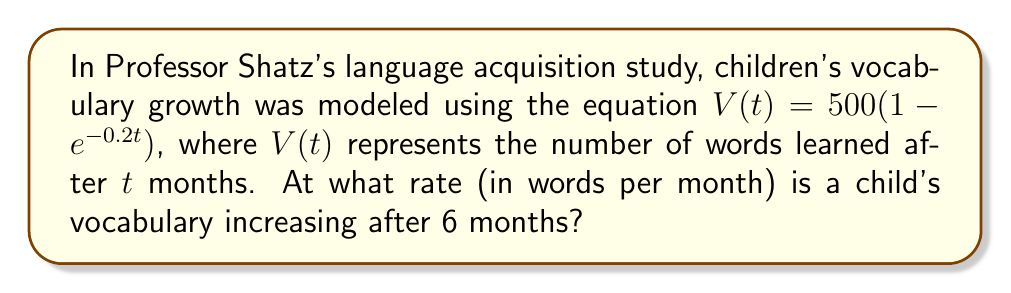Provide a solution to this math problem. To find the rate of vocabulary increase at 6 months, we need to find the derivative of the given function and evaluate it at $t = 6$.

1. The given function is $V(t) = 500(1 - e^{-0.2t})$

2. To find the derivative, we use the chain rule:
   $$\frac{dV}{dt} = 500 \cdot \frac{d}{dt}(1 - e^{-0.2t})$$
   $$\frac{dV}{dt} = 500 \cdot (0 - (-0.2)e^{-0.2t})$$
   $$\frac{dV}{dt} = 100e^{-0.2t}$$

3. This derivative represents the rate of vocabulary increase at any time $t$.

4. To find the rate at 6 months, we substitute $t = 6$ into the derivative:
   $$\frac{dV}{dt}\bigg|_{t=6} = 100e^{-0.2(6)}$$
   $$\frac{dV}{dt}\bigg|_{t=6} = 100e^{-1.2}$$

5. Calculate the result:
   $$\frac{dV}{dt}\bigg|_{t=6} \approx 30.12$$

Therefore, the child's vocabulary is increasing at a rate of approximately 30.12 words per month after 6 months.
Answer: 30.12 words/month 